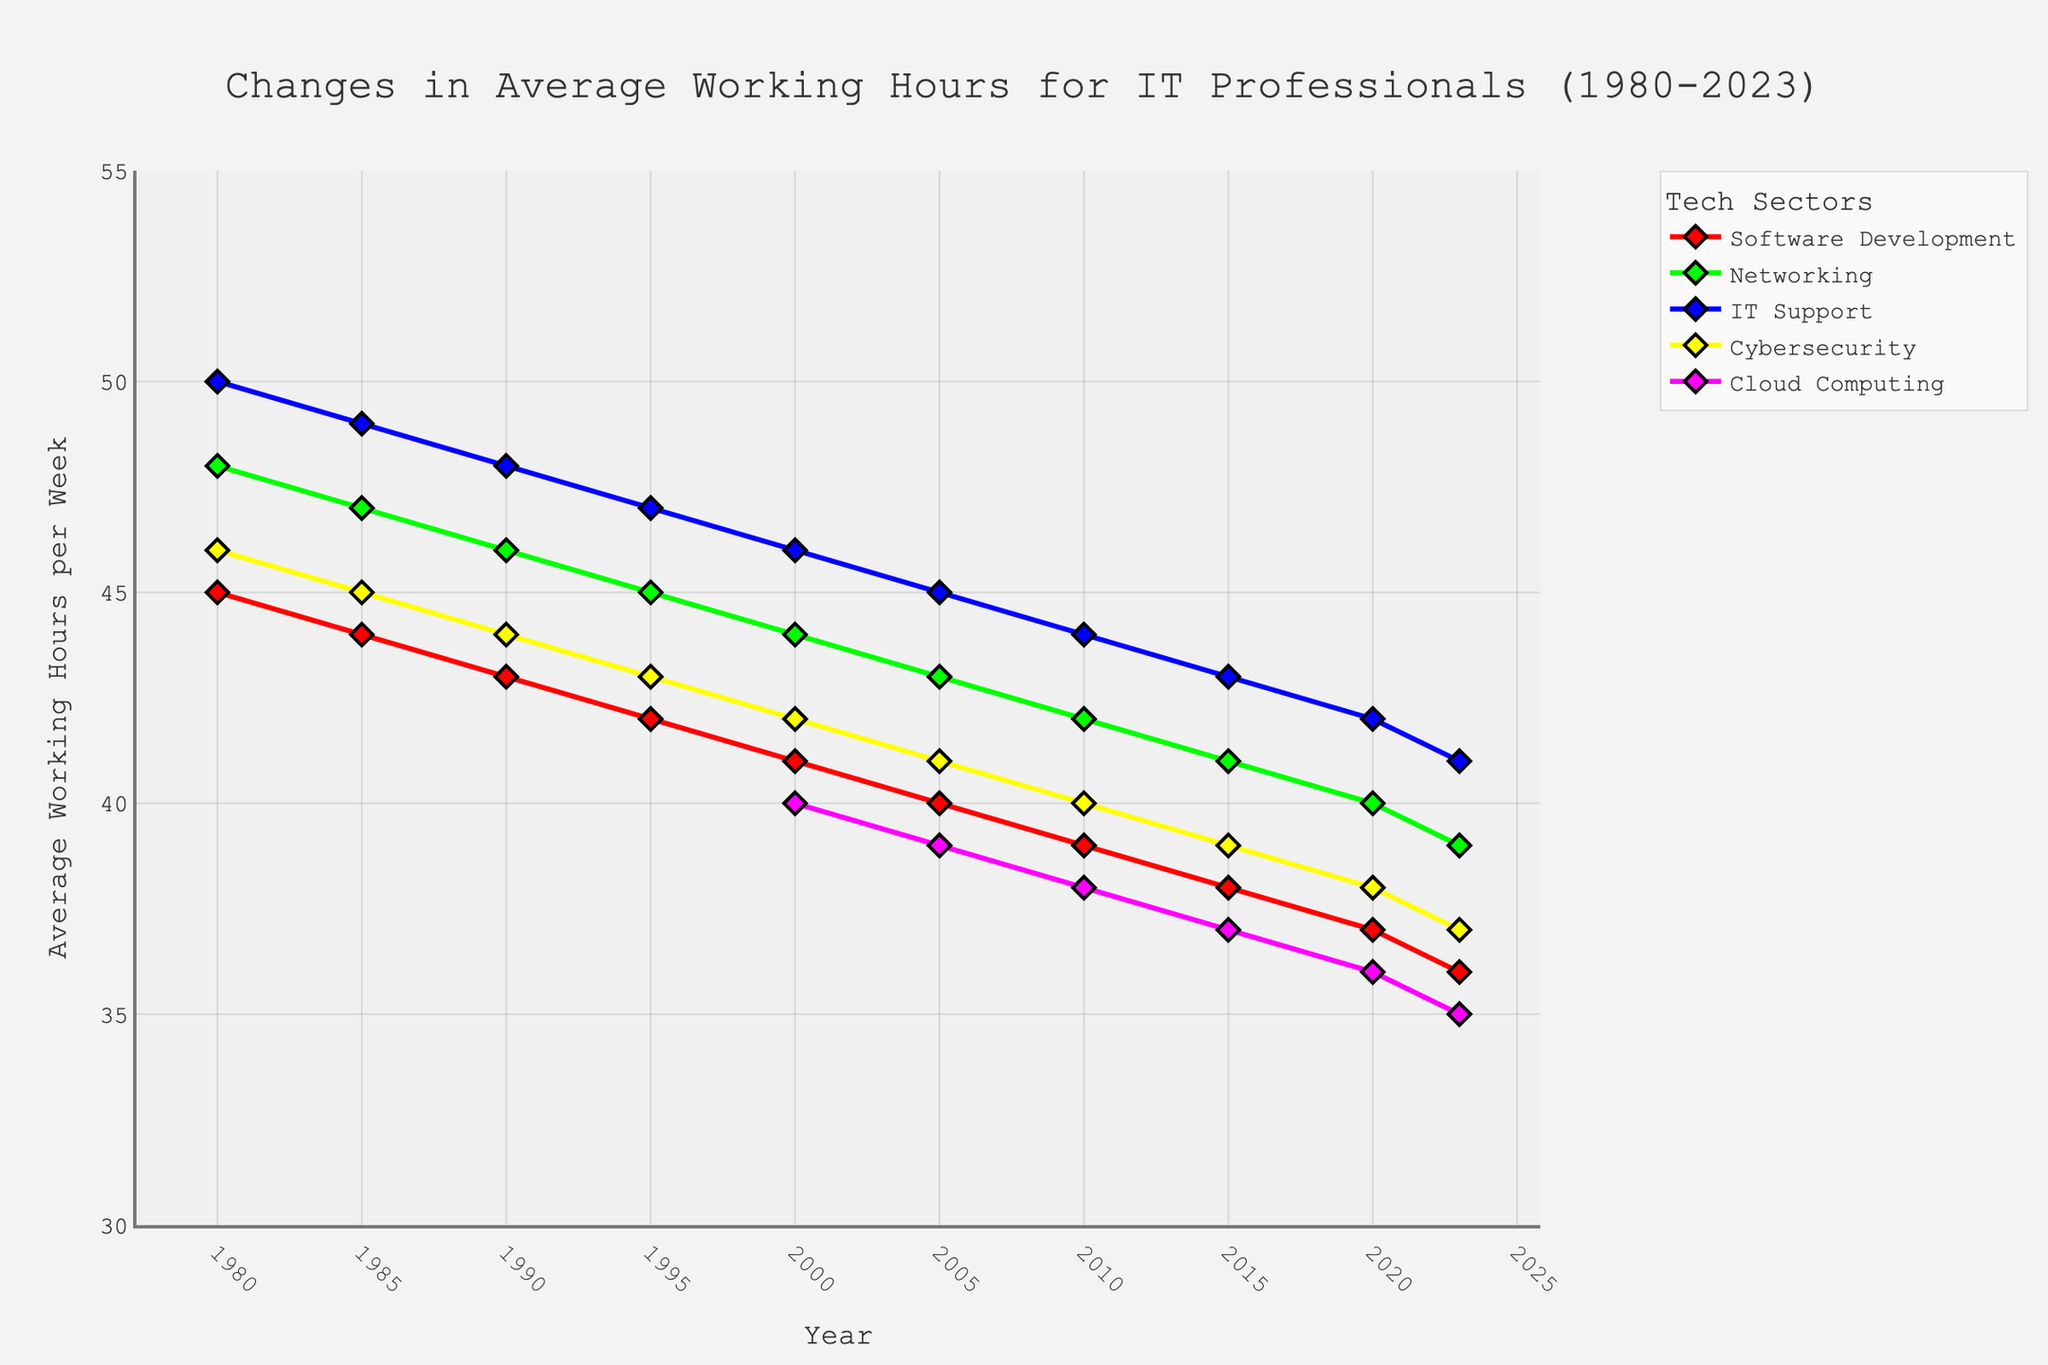Which sector had the highest average working hours in 1980? Referring to the starting year (1980), the sector with the highest average working hours was IT Support with 50 hours per week.
Answer: IT Support How did the average working hours in Software Development change from 1980 to 2023? The average working hours in Software Development decreased from 45 hours in 1980 to 36 hours in 2023. The difference can be calculated as 45 - 36 = 9 hours.
Answer: Decreased by 9 hours Which sector experienced the largest drop in average working hours between 1980 and 2023? By examining the chart, IT Support went from 50 hours to 41 hours, a 9-hour drop. Other sectors had smaller changes, for example, Networking dropped from 48 to 39 hours, an 9-hour drop as well. Both are the largest drops.
Answer: IT Support and Networking What was the average working hours for Cloud Computing in 2010? The chart shows that in 2010, the average working hours for Cloud Computing was 38 hours per week.
Answer: 38 hours Between 2000 and 2023, which sector had the most stable working hours? The sector with the least variance in working hours between 2000 and 2023 is Cybersecurity, as it shows a steady decrease without significant fluctuations from 42 to 37 hours, a decrease of only 5 hours over 23 years.
Answer: Cybersecurity Was there any sector that started reporting average working hours later than 1980? Yes, Cloud Computing started reporting average working hours from the year 2000.
Answer: Yes In which year did Networking's average working hours drop below 40 hours per week? By looking at the chart, it is in 2020 when the average working hours for Networking fell below 40 hours, showing 39 hours per week.
Answer: 2020 Which sector shows a steady and consistent decline in working hours without a period of increase? Based on the visual information, Software Development consistently declined from 45 hours in 1980 to 36 hours in 2023 without any periods of increase.
Answer: Software Development What is the average of the average working hours in Software Development and IT Support in 2023? The average working hours for Software Development in 2023 is 36, and for IT Support, it is 41. Their average is (36 + 41) / 2 = 38.5 hours per week.
Answer: 38.5 hours Comparing 2000 to 2023, which sector had the smallest reduction in working hours? Comparing the values between 2000 and 2023, the Cybersecurity sector went from 42 to 37, a reduction of 5 hours which is the smallest reduction among the sectors listed.
Answer: Cybersecurity 